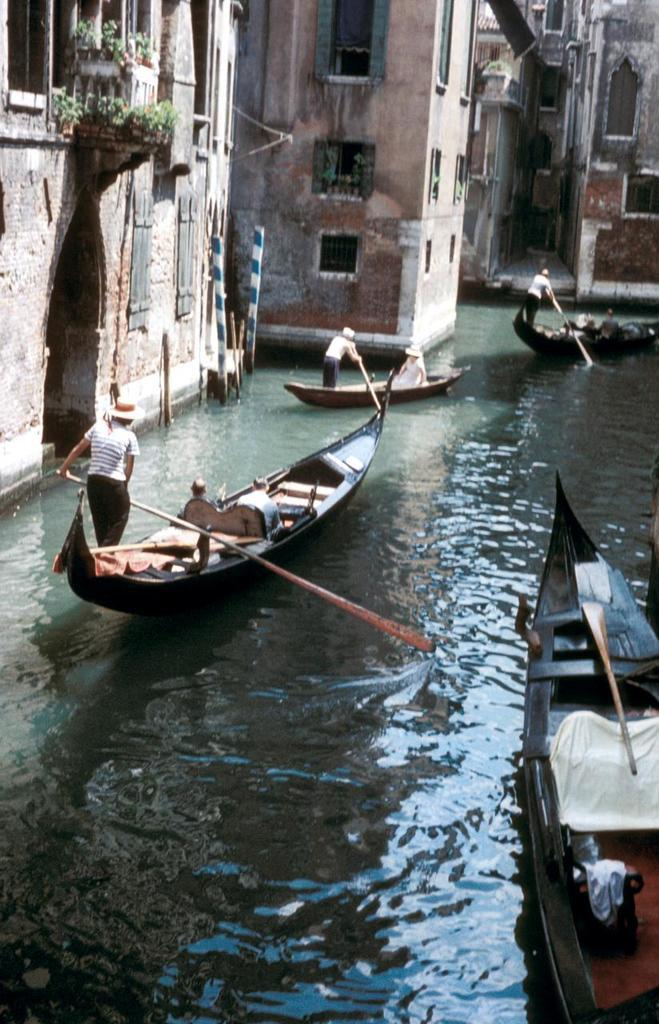What type of vehicles are in the image? There are boats in the image. What are the people in the boats doing? People are rowing the boats. Where are the boats located? The boats are in a river. What can be seen near the river? There are buildings and plants near the river. What features can be observed on the buildings? Windows are visible on the buildings. What type of lace is being used to tie the boats together in the image? There is no lace present in the image, nor are the boats tied together. 